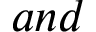Convert formula to latex. <formula><loc_0><loc_0><loc_500><loc_500>a n d</formula> 